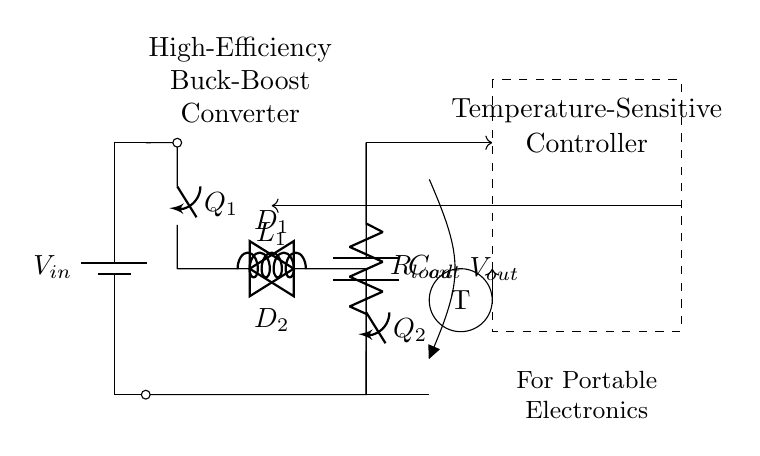What type of converter is depicted? The circuit diagram shows a buck-boost converter, which is designed to step down or step up voltage based on input conditions, indicated by the configuration and the switching elements present.
Answer: Buck-Boost Converter How many switches are used in the circuit? The circuit contains two switches, labeled as Q1 and Q2, which are essential for controlling the current flow in the buck-boost conversion process.
Answer: Two What is the role of the inductor in this converter? The inductor serves to store energy during the switch operation, either charging or discharging based on the control method, critical for both buck and boost behavior in the circuit operation.
Answer: Energy storage Which component acts as the load in this circuit? The load is represented by R load, which receives power from the converter and is fundamental in determining the output voltage and current characteristics.
Answer: R load What type of feedback is used in this circuit? The circuit employs feedback from the output voltage to the controller, allowing for adjustments based on detected conditions to regulate the output effectively.
Answer: Voltage feedback How does the temperature-sensitive feature affect the regulator? The temperature-sensitive controller monitors the temperature and adjusts the operation of the converter to protect components from overheating and ensure efficient energy management based on thermal conditions.
Answer: Thermal regulation What is the function of the capacitors in the circuit? The capacitors, specifically C out, serve to smooth out fluctuations in output voltage and provide stability in the power supply, essential for sensitive electronic devices.
Answer: Voltage smoothing 